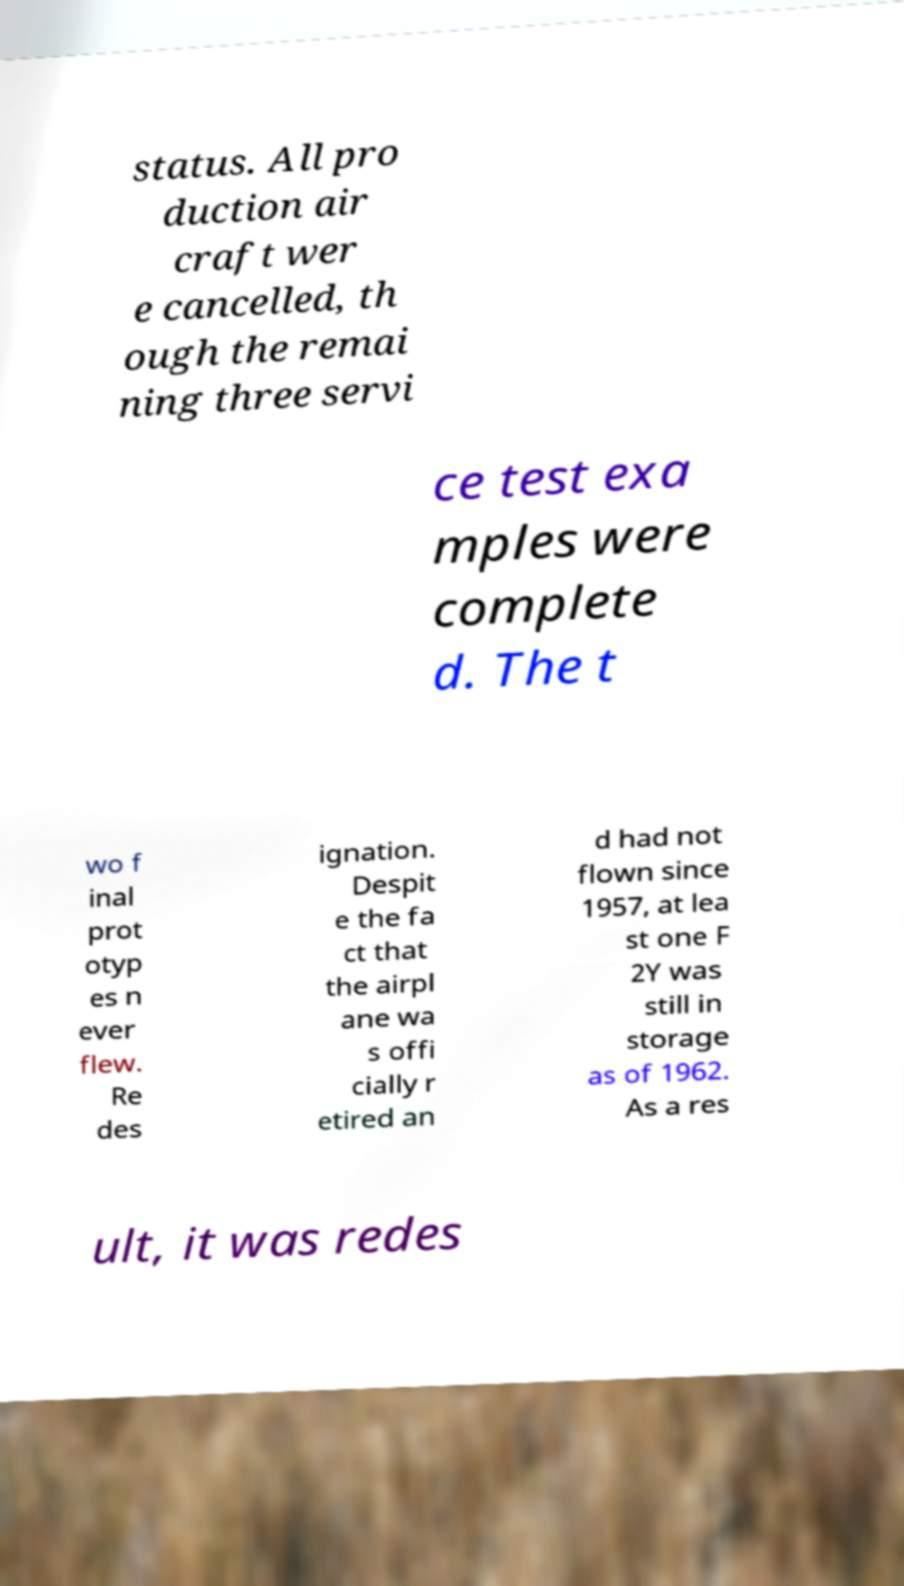There's text embedded in this image that I need extracted. Can you transcribe it verbatim? status. All pro duction air craft wer e cancelled, th ough the remai ning three servi ce test exa mples were complete d. The t wo f inal prot otyp es n ever flew. Re des ignation. Despit e the fa ct that the airpl ane wa s offi cially r etired an d had not flown since 1957, at lea st one F 2Y was still in storage as of 1962. As a res ult, it was redes 